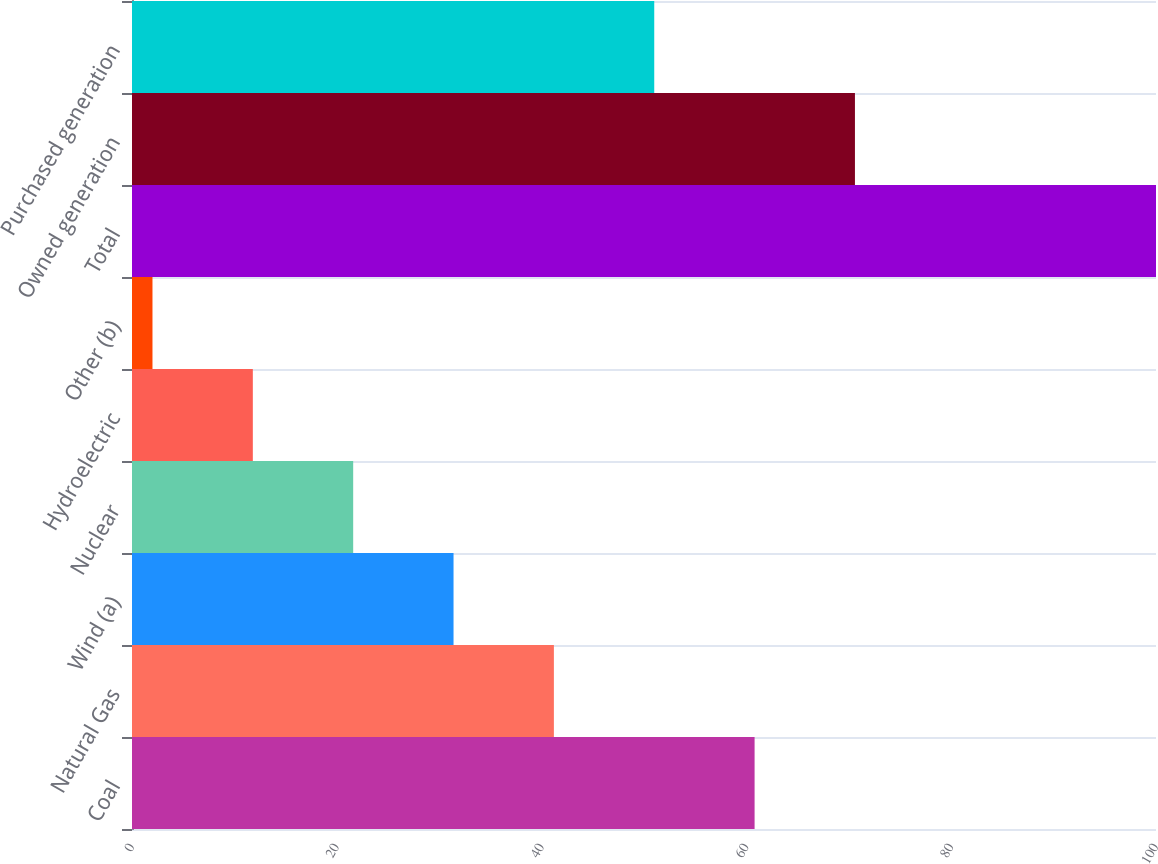<chart> <loc_0><loc_0><loc_500><loc_500><bar_chart><fcel>Coal<fcel>Natural Gas<fcel>Wind (a)<fcel>Nuclear<fcel>Hydroelectric<fcel>Other (b)<fcel>Total<fcel>Owned generation<fcel>Purchased generation<nl><fcel>60.8<fcel>41.2<fcel>31.4<fcel>21.6<fcel>11.8<fcel>2<fcel>100<fcel>70.6<fcel>51<nl></chart> 